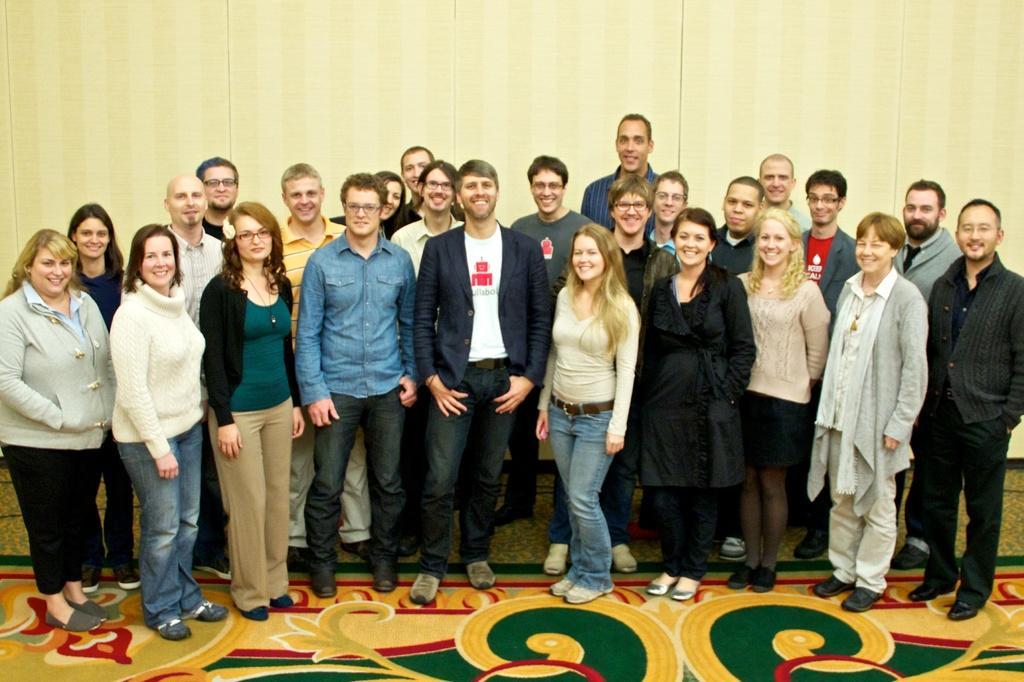Please provide a concise description of this image. In this image we can see few people standing and a carpet on the floor and wall in the background. 